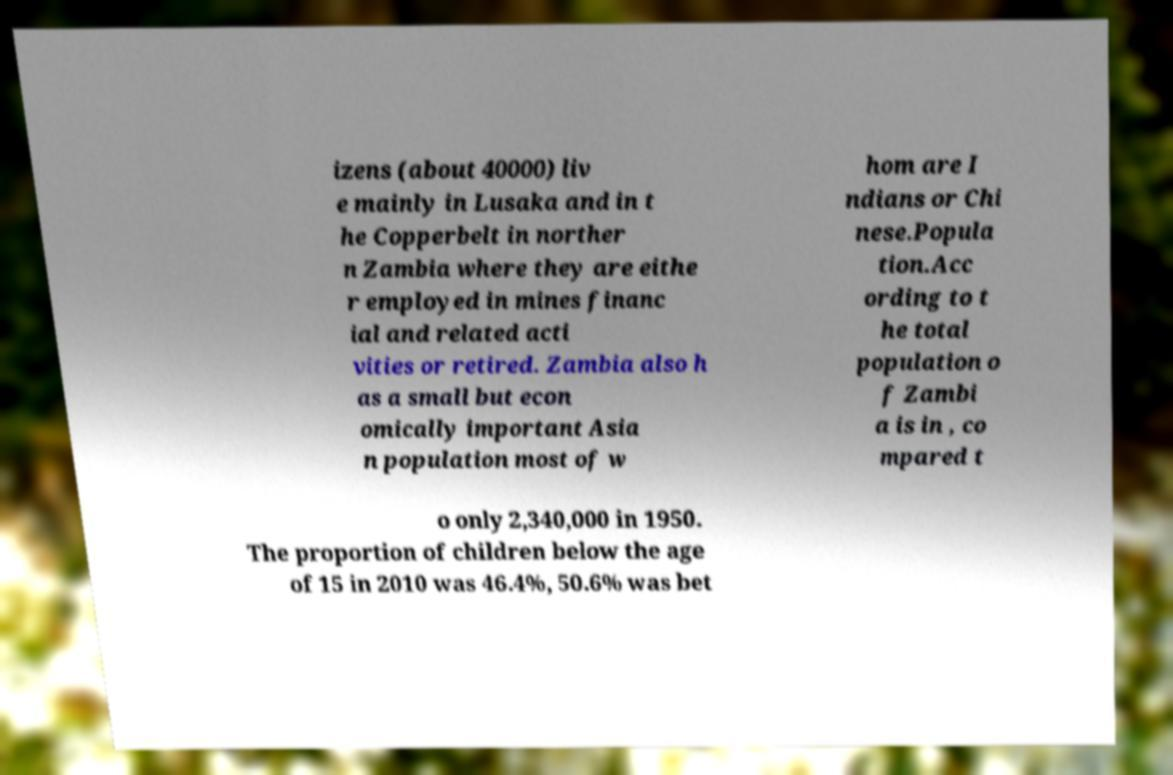Please identify and transcribe the text found in this image. izens (about 40000) liv e mainly in Lusaka and in t he Copperbelt in norther n Zambia where they are eithe r employed in mines financ ial and related acti vities or retired. Zambia also h as a small but econ omically important Asia n population most of w hom are I ndians or Chi nese.Popula tion.Acc ording to t he total population o f Zambi a is in , co mpared t o only 2,340,000 in 1950. The proportion of children below the age of 15 in 2010 was 46.4%, 50.6% was bet 